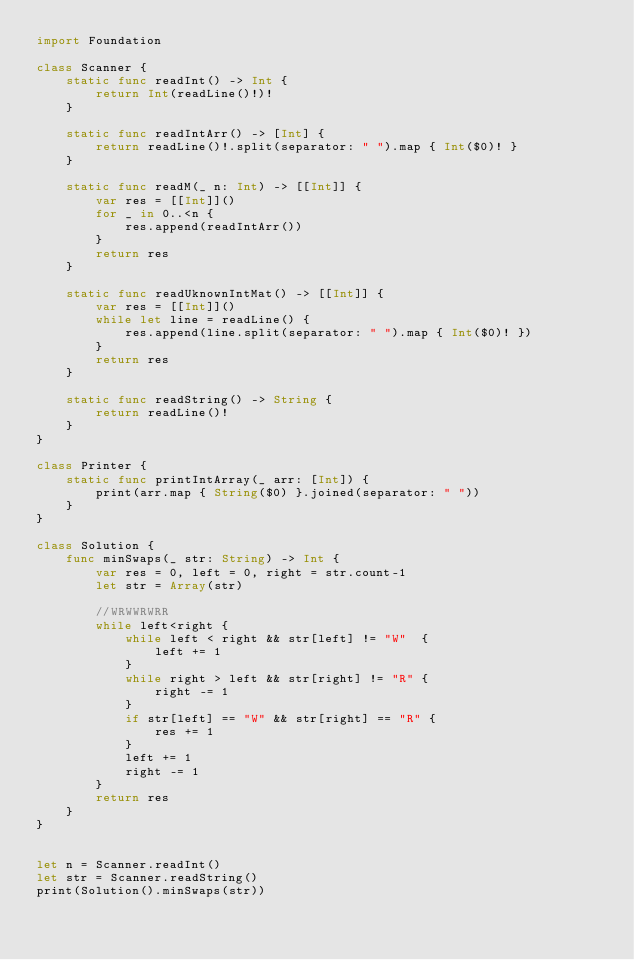<code> <loc_0><loc_0><loc_500><loc_500><_Swift_>import Foundation

class Scanner {
    static func readInt() -> Int {
        return Int(readLine()!)!
    }
    
    static func readIntArr() -> [Int] {
        return readLine()!.split(separator: " ").map { Int($0)! }
    }
    
    static func readM(_ n: Int) -> [[Int]] {
        var res = [[Int]]()
        for _ in 0..<n {
            res.append(readIntArr())
        }
        return res
    }
    
    static func readUknownIntMat() -> [[Int]] {
        var res = [[Int]]()
        while let line = readLine() {
            res.append(line.split(separator: " ").map { Int($0)! })
        }
        return res
    }
    
    static func readString() -> String {
        return readLine()!
    }
}

class Printer {
    static func printIntArray(_ arr: [Int]) {
        print(arr.map { String($0) }.joined(separator: " "))
    }
}

class Solution {
    func minSwaps(_ str: String) -> Int {
        var res = 0, left = 0, right = str.count-1
        let str = Array(str)
        
        //WRWWRWRR
        while left<right {
            while left < right && str[left] != "W"  {
                left += 1
            }
            while right > left && str[right] != "R" {
                right -= 1
            }
            if str[left] == "W" && str[right] == "R" {
                res += 1
            }
            left += 1
            right -= 1
        }
        return res
    }
}


let n = Scanner.readInt()
let str = Scanner.readString()
print(Solution().minSwaps(str))
</code> 